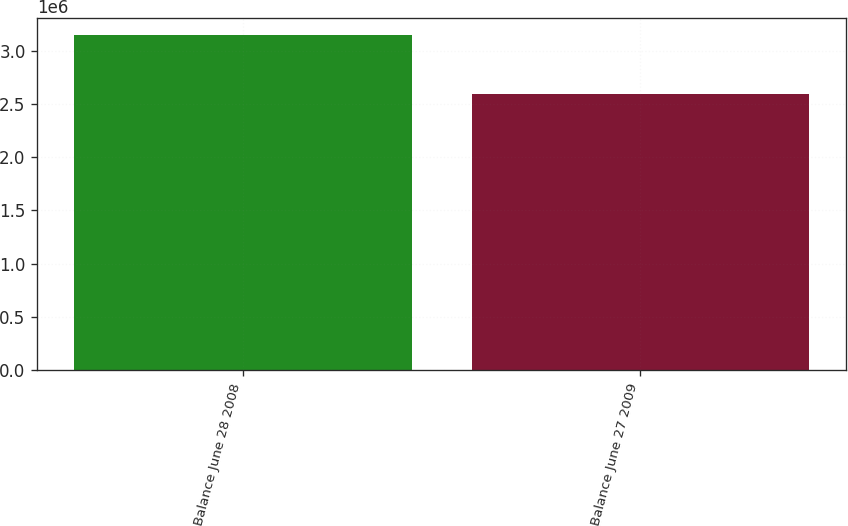Convert chart to OTSL. <chart><loc_0><loc_0><loc_500><loc_500><bar_chart><fcel>Balance June 28 2008<fcel>Balance June 27 2009<nl><fcel>3.14781e+06<fcel>2.59446e+06<nl></chart> 